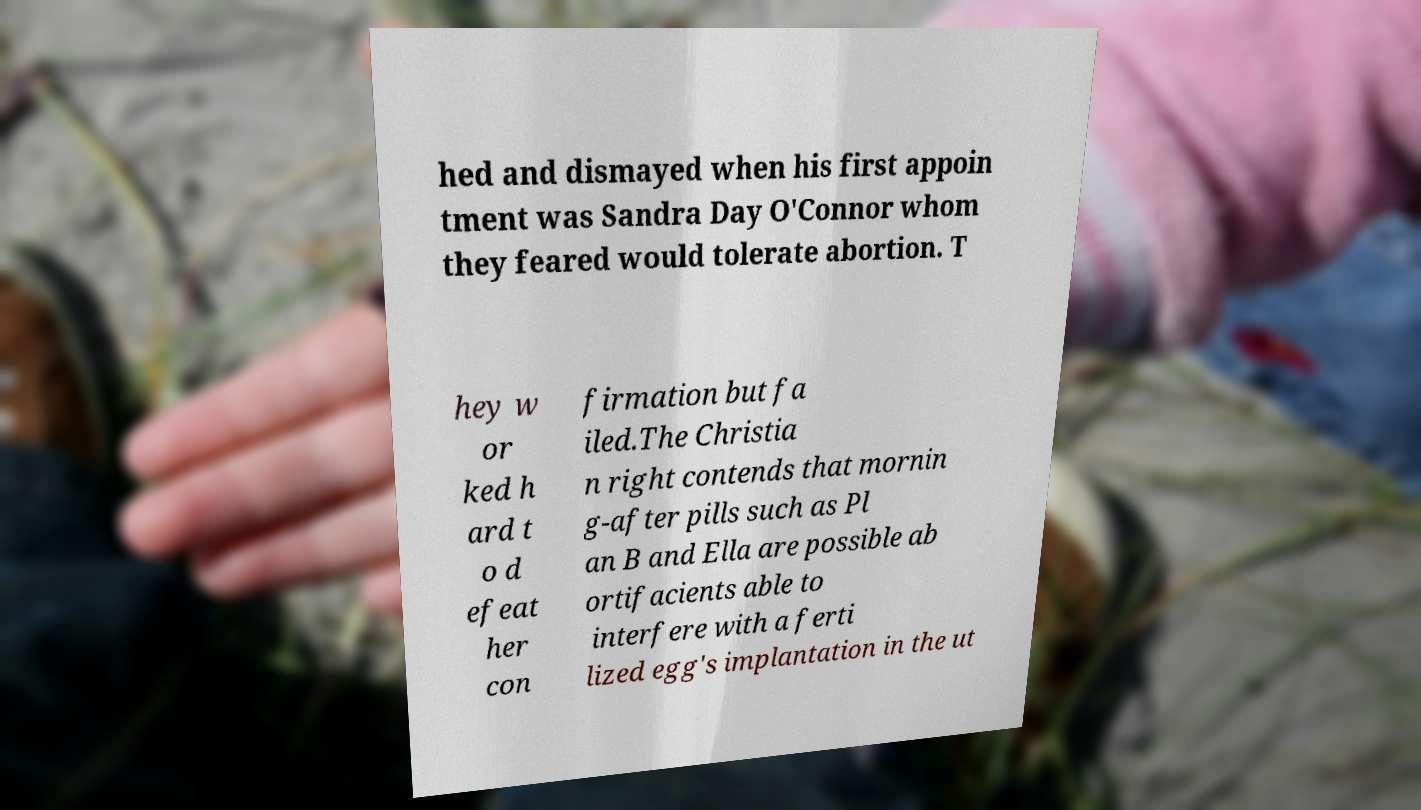Can you read and provide the text displayed in the image?This photo seems to have some interesting text. Can you extract and type it out for me? hed and dismayed when his first appoin tment was Sandra Day O'Connor whom they feared would tolerate abortion. T hey w or ked h ard t o d efeat her con firmation but fa iled.The Christia n right contends that mornin g-after pills such as Pl an B and Ella are possible ab ortifacients able to interfere with a ferti lized egg's implantation in the ut 